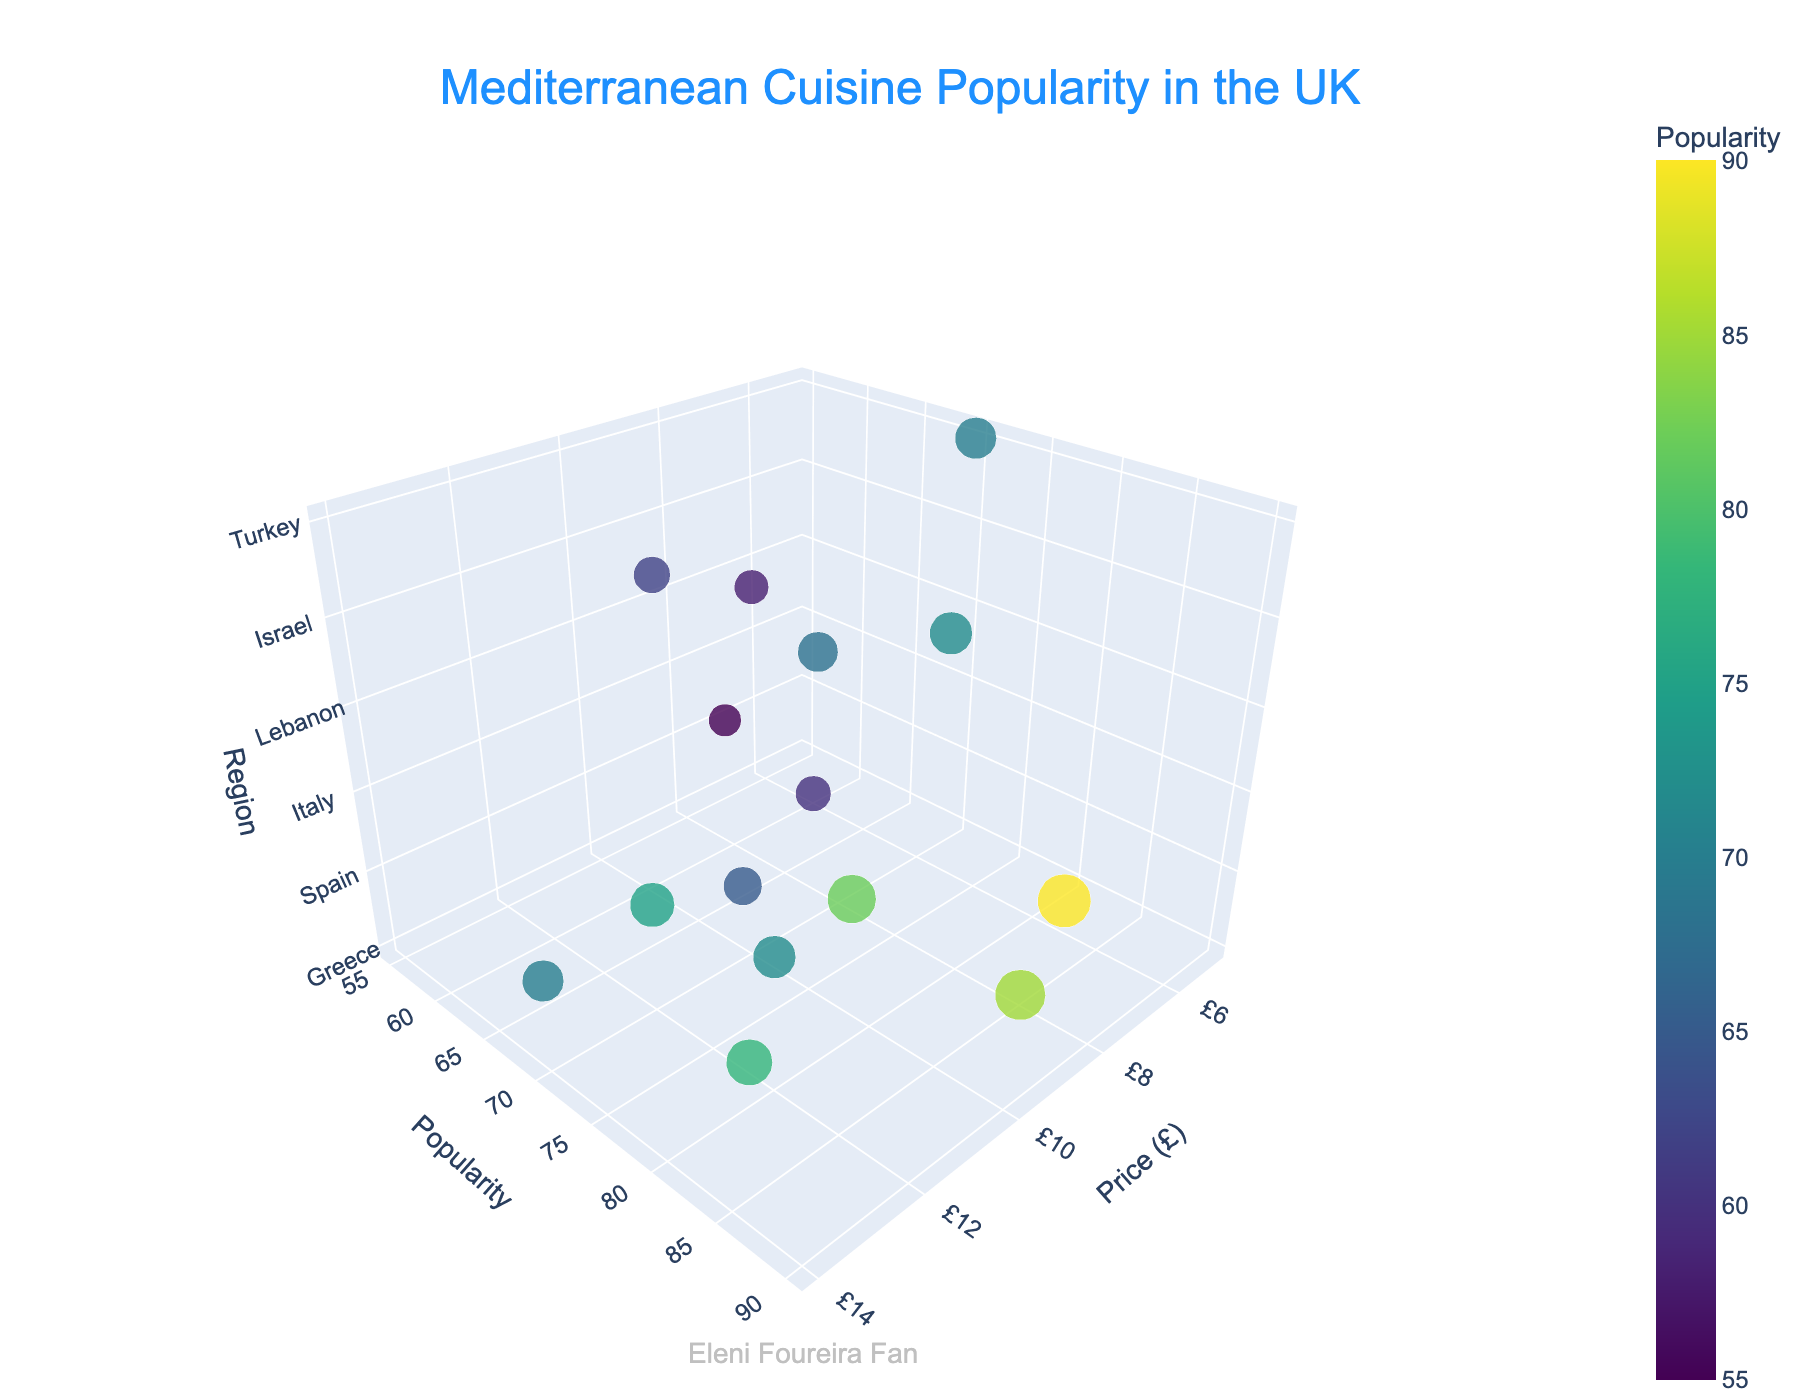What is the title of the plot? The title of the plot is displayed prominently at the top of the figure.
Answer: Mediterranean Cuisine Popularity in the UK How is the size of the markers determined? The size of the markers is calculated based on the popularity of each dish. Larger markers indicate higher popularity.
Answer: By popularity What region has the dish with the highest popularity? By examining the highest point on the y-axis (popularity axis) and identifying its z-axis (region) value, we see it corresponds to the Italian region.
Answer: Italy Which dish has the lowest price point, and what is its popularity? Look for the marker on the x-axis with the lowest price value (£). The corresponding dish is "Baklava," with a popularity value of 70.
Answer: Baklava, 70 Compare the popularity of Greek Salad and Moussaka. Which one is more popular? Identify the markers for Greek Salad and Moussaka and compare their y-axis values (popularity). Greek Salad's popularity is higher than Moussaka's.
Answer: Greek Salad Are dishes from Greece generally more popular than dishes from Lebanon? Average the popularity values for dishes from Greece and Lebanon, respectively. Greece has popularity values of 85, 78, 72, 65, and 60, which sum to 360. Lebanon has popularity values of 68, 72, and 58, which sum to 198. Dividing each sum by the number of dishes: Greece has (360/5 = 72) and Lebanon (198/3 = 66). Greece is more popular on average.
Answer: Yes What's the overall trend between price point and popularity? By observing the general distribution of markers, identify whether higher-priced dishes tend to have higher/lower popularity values. There seems to be no strong correlation visible.
Answer: No strong trend Which country has most dishes in this plot? By counting the distinct markers for each country present on the z-axis, you see Greece appears five times, the most among all regions.
Answer: Greece What is the price point and popularity of the falafel from Lebanon? Look for the marker labeled "Falafel" during the hover action. The price point is £8, and its popularity is 68.
Answer: £8, 68 What approximates the average popularity of all dishes shown in the plot? Sum up the popularity values for all dishes (85, 78, 72, 65, 60, 70, 55, 82, 90, 75, 68, 72, 62, 58, 70) which equals 1062, then divide by the number of dishes (15) to get the average. 1062 / 15 = 70.8.
Answer: 70.8 